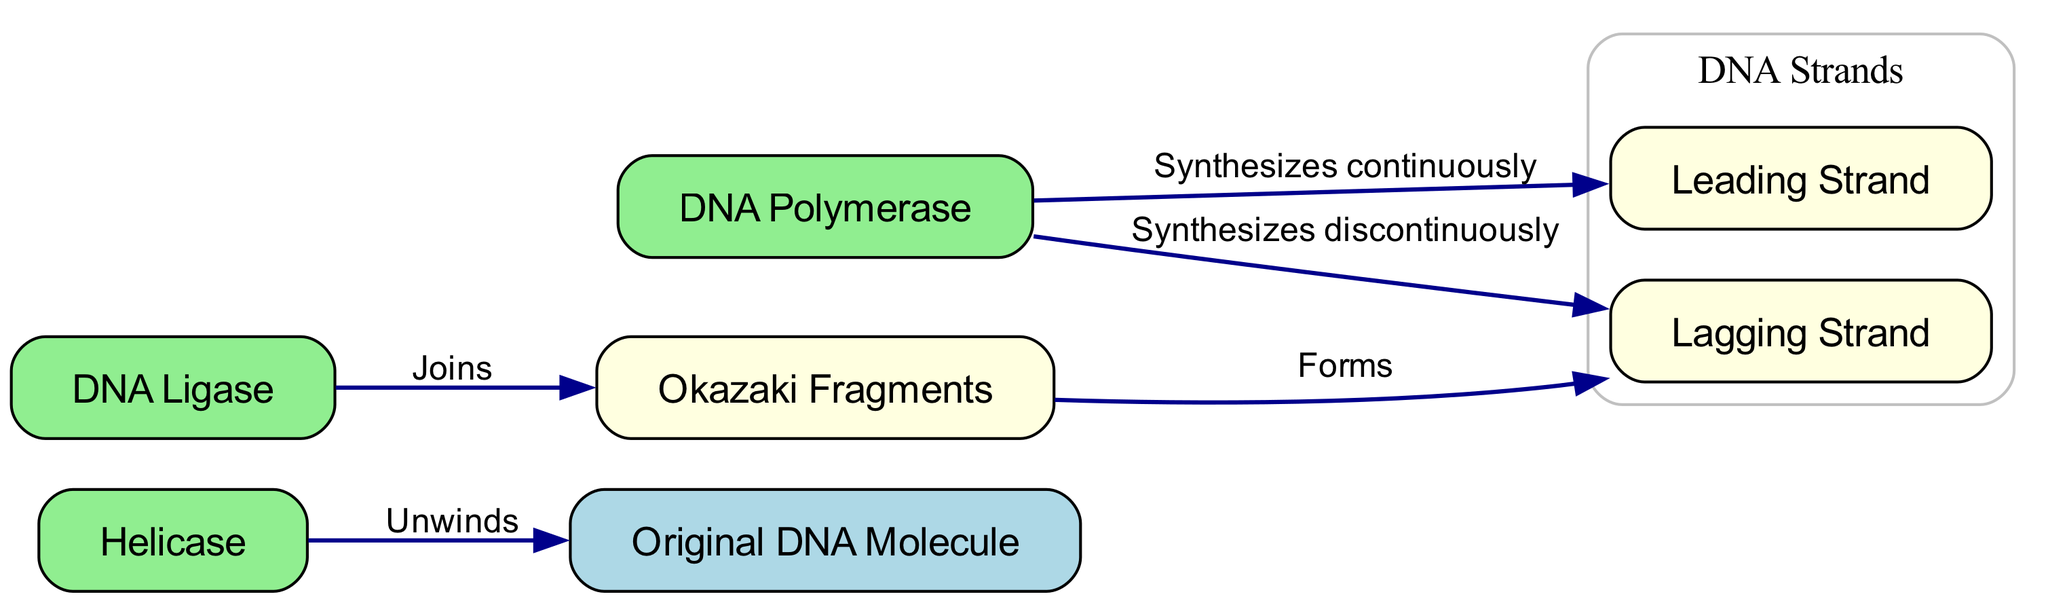What is the role of helicase in the DNA replication diagram? The diagram indicates that helicase unwinds the original DNA molecule, which is essential for replication. This can be inferred by following the edge that connects helicase to the original DNA molecule, labeled "Unwinds".
Answer: Unwinds How many main enzymes are shown in the diagram? The diagram lists three main enzymes: helicase, DNA polymerase, and ligase. This can be counted directly from the nodes labeled as enzymes.
Answer: 3 What forms the lagging strand during DNA replication? The diagram shows that the lagging strand is synthesized discontinuously by DNA polymerase and is formed from Okazaki fragments. This means that Okazaki fragments contribute to the structure of the lagging strand.
Answer: Okazaki fragments Which strand of DNA is synthesized continuously? The diagram specifies that the leading strand is synthesized continuously by DNA polymerase. This relationship is indicated by the labeled edge connecting DNA polymerase to the leading strand.
Answer: Leading Strand What is the function of DNA ligase in the diagram? According to the diagram, DNA ligase joins Okazaki fragments. This can be understood by following the edge from ligase to Okazaki fragments, labeled "Joins".
Answer: Joins Explain how Okazaki fragments are related to the lagging strand. The diagram illustrates that Okazaki fragments are formed and then join together to create the lagging strand. By tracing the connections, the relationship shows that Okazaki fragments are a fundamental part of the lagging strand's structure.
Answer: Forms How is genetic material duplication initiated in the diagram? The diagram suggests that genetic material duplication begins with helicase unwinding the original DNA molecule. This is evident from the initial interaction between helicase and the original DNA molecule to start the replication process.
Answer: Unwinds What does DNA polymerase synthesize on the leading and lagging strands? In the diagram, DNA polymerase synthesizes the leading strand continuously and the lagging strand discontinuously. Both relationships are indicated by the relevant directed edges to each strand from DNA polymerase.
Answer: Leading Strand, Lagging Strand What indicates the direction of replication on the lagging strand? The diagram illustrates that the lagging strand is synthesized discontinuously, which is indicated by the presence of Okazaki fragments and the associated connection from DNA polymerase to the lagging strand depicting that it's created in segments.
Answer: Discontinuously 